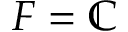Convert formula to latex. <formula><loc_0><loc_0><loc_500><loc_500>F = \mathbb { C }</formula> 